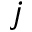Convert formula to latex. <formula><loc_0><loc_0><loc_500><loc_500>j</formula> 